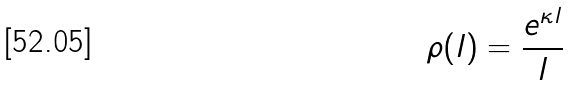Convert formula to latex. <formula><loc_0><loc_0><loc_500><loc_500>\rho ( l ) = \frac { e ^ { \kappa l } } { l }</formula> 